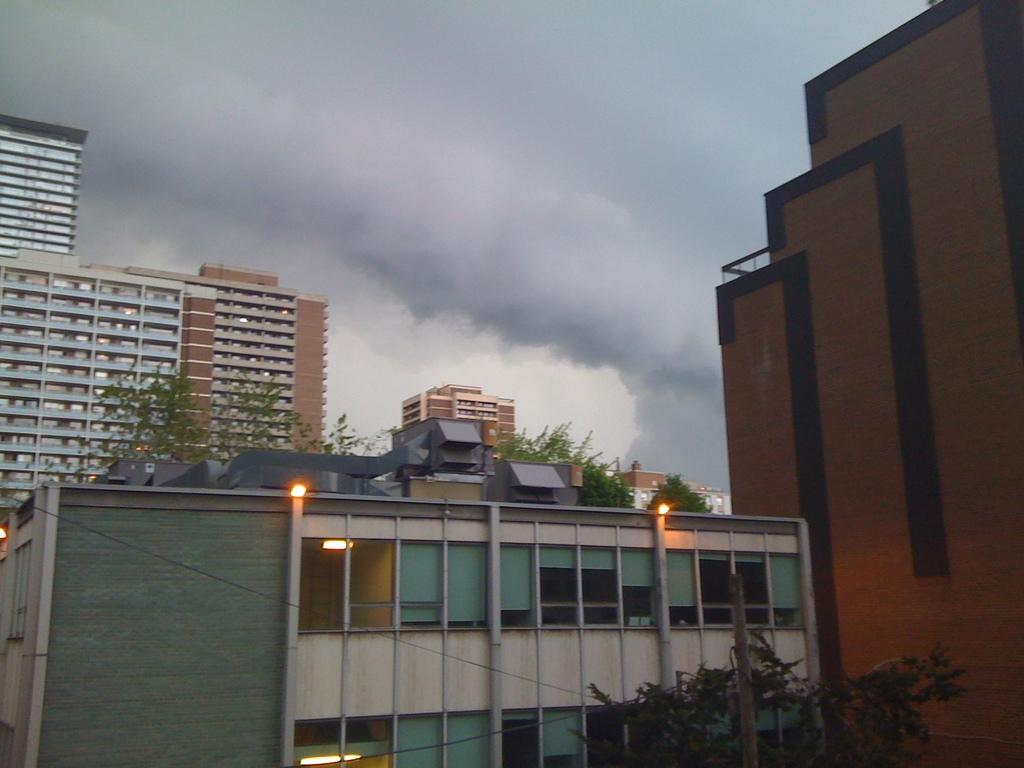What type of structures are present in the image? There are buildings in the image. What can be seen behind the buildings? There are trees behind the buildings. What feature do the buildings have? The buildings have lights. What is visible at the top of the image? The sky is visible at the top of the image. What type of bucket can be seen on the road in the image? There is no bucket or road present in the image; it features buildings, trees, lights, and the sky. 